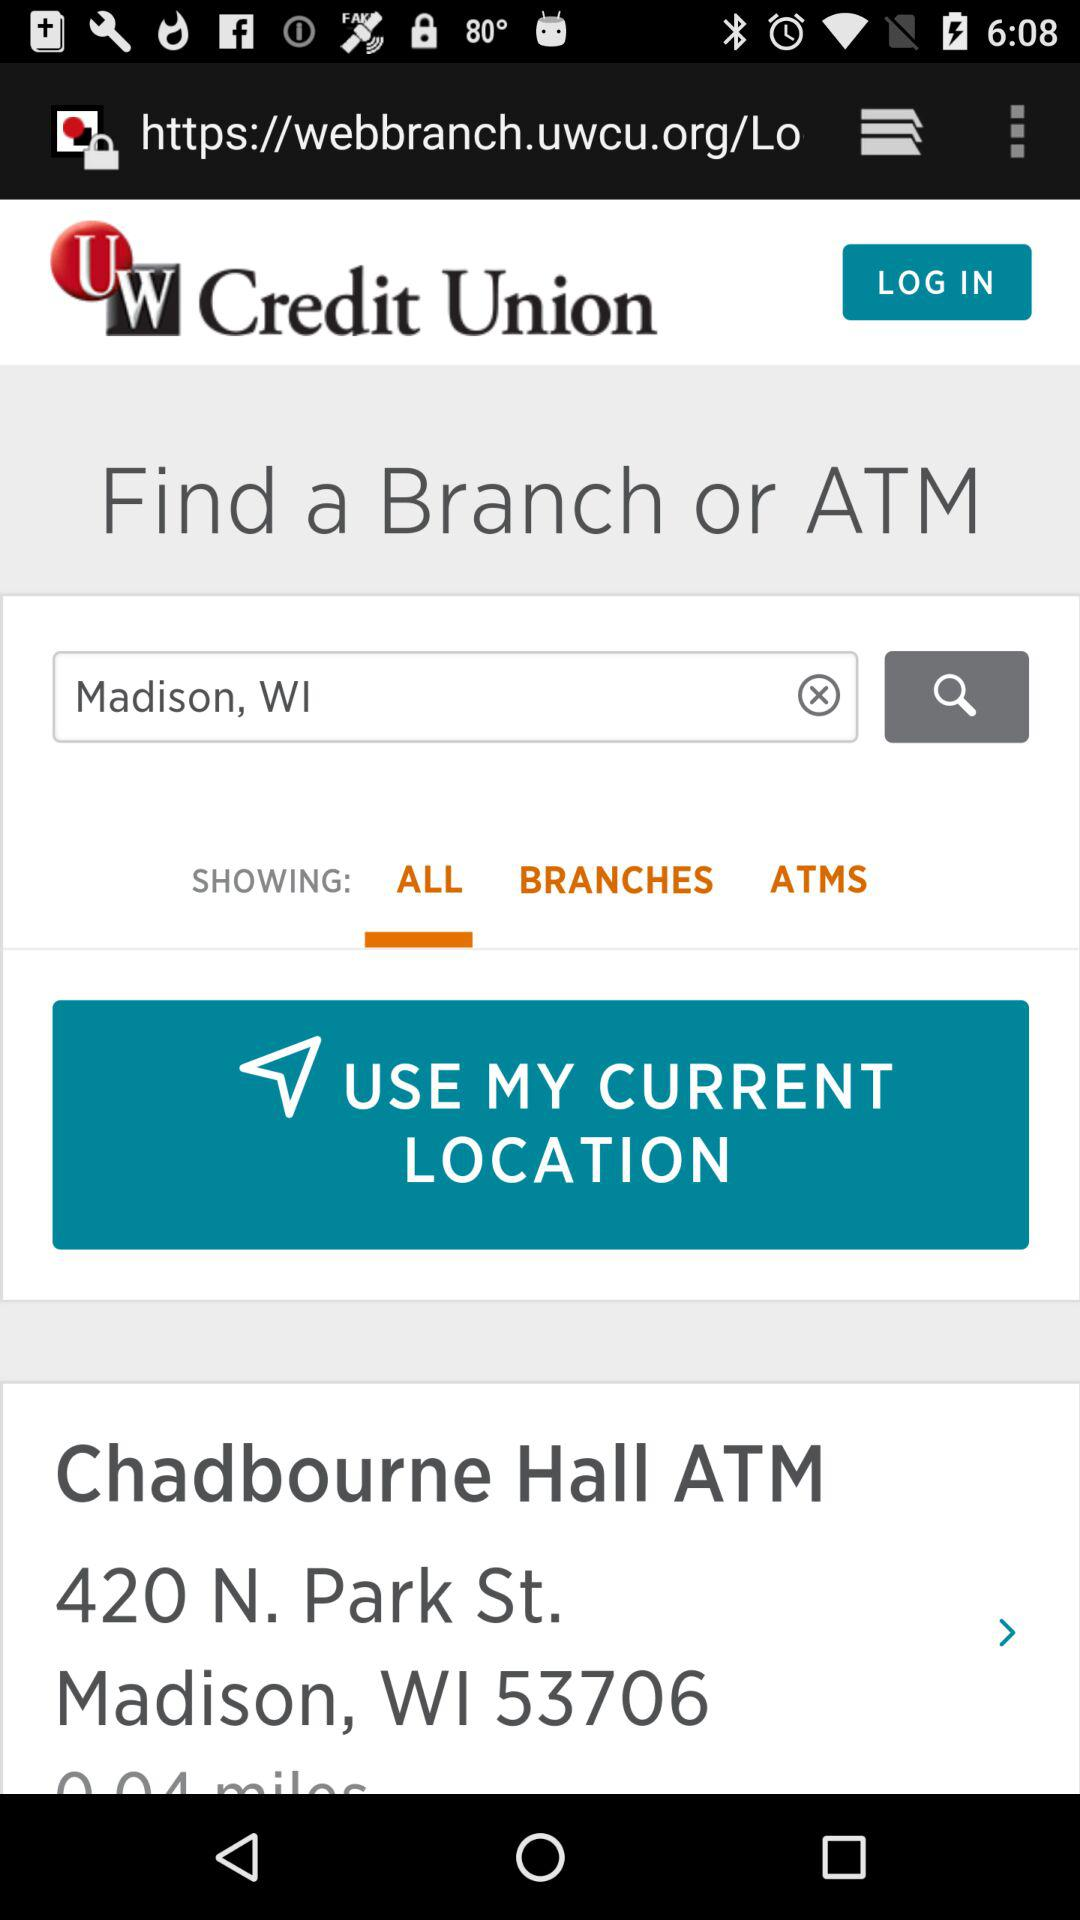What is the entered location shown on the screen? The entered location is Madison, WI. 